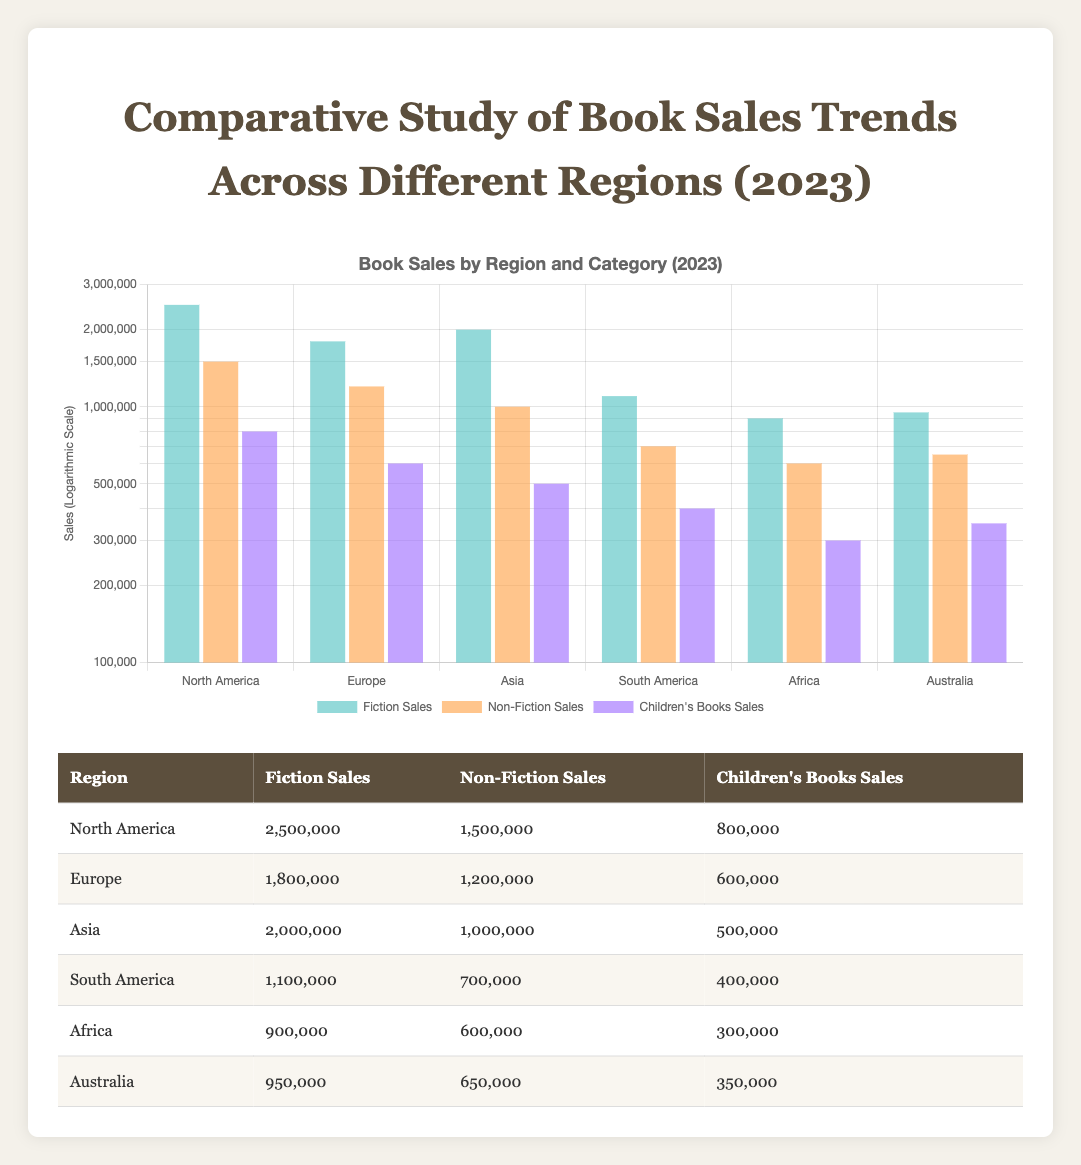What are the fiction sales in North America? Referring to the table, the fiction sales for North America is listed as 2,500,000.
Answer: 2,500,000 Which region has the highest non-fiction sales? Looking at the non-fiction sales column, the highest value is 1,500,000 in North America.
Answer: North America What is the total sales of children's books across all regions? To find the total, we sum the children's books sales: 800,000 (North America) + 600,000 (Europe) + 500,000 (Asia) + 400,000 (South America) + 300,000 (Africa) + 350,000 (Australia) = 3,550,000.
Answer: 3,550,000 Is Asia's fiction sales greater than Africa's fiction sales? Asia's fiction sales is 2,000,000, while Africa's is 900,000. Since 2,000,000 is greater than 900,000, the statement is true.
Answer: Yes What is the average non-fiction sales in Europe and South America? The non-fiction sales in Europe is 1,200,000 and in South America is 700,000. The average is calculated as (1,200,000 + 700,000) / 2 = 950,000.
Answer: 950,000 Which region has the least children's books sales? By examining the children's books sales, Australia has 350,000, and Africa has 300,000, which is the smallest value among all regions.
Answer: Africa What is the difference in fiction sales between North America and Europe? The fiction sales in North America is 2,500,000 and in Europe is 1,800,000. The difference is 2,500,000 - 1,800,000 = 700,000.
Answer: 700,000 Is the total sales of fiction books greater than the total sales of non-fiction books in North America? The total fiction sales in North America is 2,500,000 and non-fiction sales is 1,500,000. Since 2,500,000 is greater than 1,500,000, the answer is yes.
Answer: Yes What is the combined total of fiction and children's books sales in South America? South America's fiction sales is 1,100,000 and children's books sales is 400,000. The combined total is 1,100,000 + 400,000 = 1,500,000.
Answer: 1,500,000 